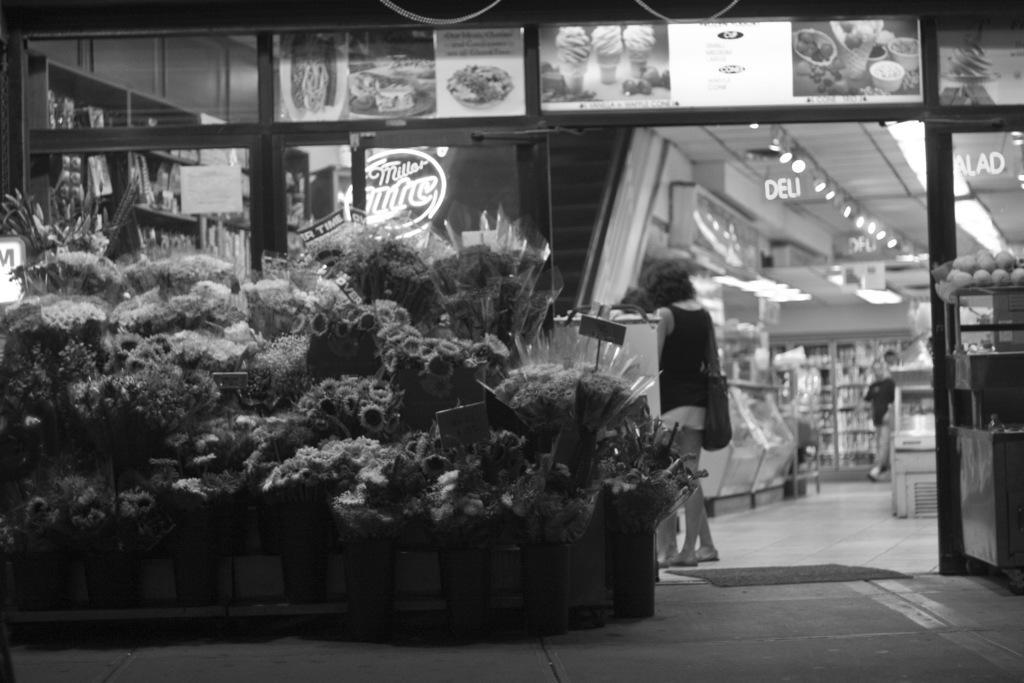Describe this image in one or two sentences. In this picture we can see flower bouquets,people and in the background we can see posts,lights,few more objects. 